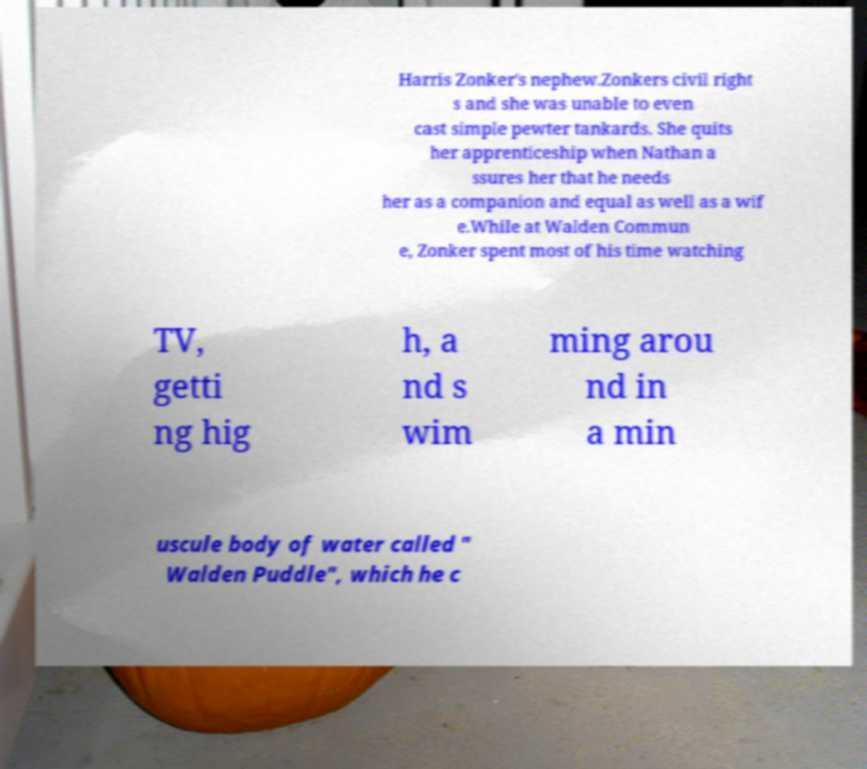What messages or text are displayed in this image? I need them in a readable, typed format. Harris Zonker's nephew.Zonkers civil right s and she was unable to even cast simple pewter tankards. She quits her apprenticeship when Nathan a ssures her that he needs her as a companion and equal as well as a wif e.While at Walden Commun e, Zonker spent most of his time watching TV, getti ng hig h, a nd s wim ming arou nd in a min uscule body of water called " Walden Puddle", which he c 